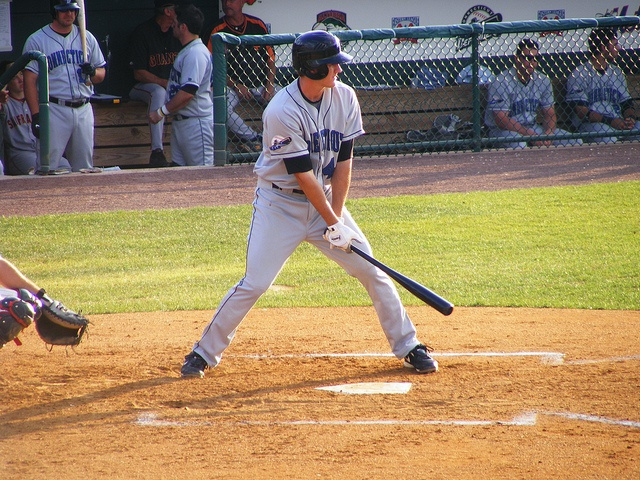Describe the objects in this image and their specific colors. I can see people in gray, darkgray, black, and brown tones, people in gray, black, and darkgray tones, people in gray, black, and darkgray tones, people in gray, black, maroon, and navy tones, and people in gray, black, and maroon tones in this image. 